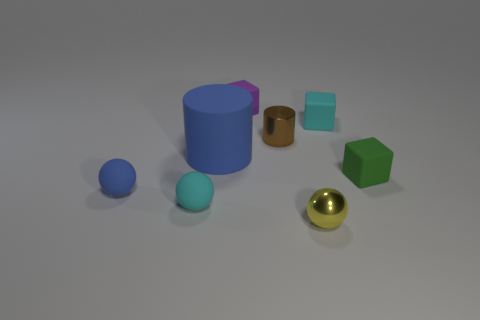There is a tiny blue thing; are there any brown metal things left of it?
Your answer should be compact. No. The tiny object that is both behind the brown cylinder and on the right side of the yellow metal thing is made of what material?
Offer a terse response. Rubber. What is the color of the other thing that is the same shape as the brown thing?
Your answer should be compact. Blue. There is a small cyan thing that is behind the tiny green matte cube; is there a cube that is in front of it?
Your response must be concise. Yes. The yellow ball has what size?
Provide a short and direct response. Small. There is a thing that is both to the right of the yellow ball and behind the big blue cylinder; what shape is it?
Offer a terse response. Cube. What number of cyan things are either small matte blocks or shiny balls?
Give a very brief answer. 1. Does the blue object in front of the rubber cylinder have the same size as the metal object in front of the large object?
Provide a succinct answer. Yes. What number of objects are blue matte balls or small yellow shiny objects?
Give a very brief answer. 2. Is there a tiny cyan metal thing of the same shape as the brown thing?
Provide a short and direct response. No. 